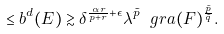<formula> <loc_0><loc_0><loc_500><loc_500>\leq b ^ { d } ( E ) \gtrsim \delta ^ { \frac { \alpha r } { p + r } + \epsilon } \lambda ^ { \tilde { p } } \ g r a ( F ) ^ { \frac { \tilde { p } } { \tilde { q } } } .</formula> 